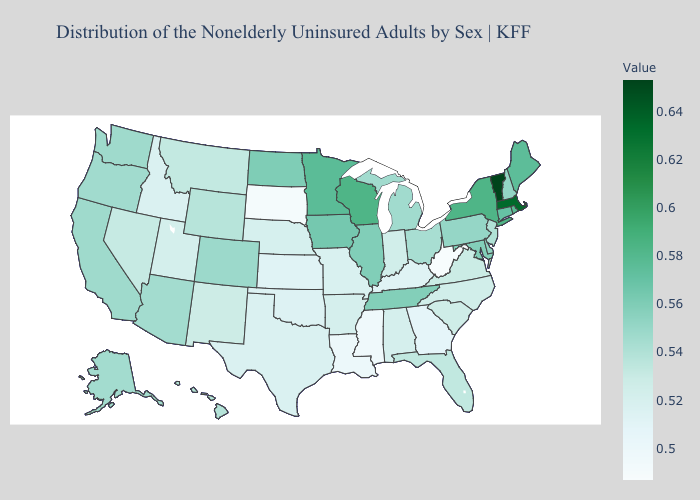Among the states that border North Dakota , which have the highest value?
Short answer required. Minnesota. Does the map have missing data?
Concise answer only. No. Among the states that border New York , does Vermont have the highest value?
Quick response, please. Yes. 